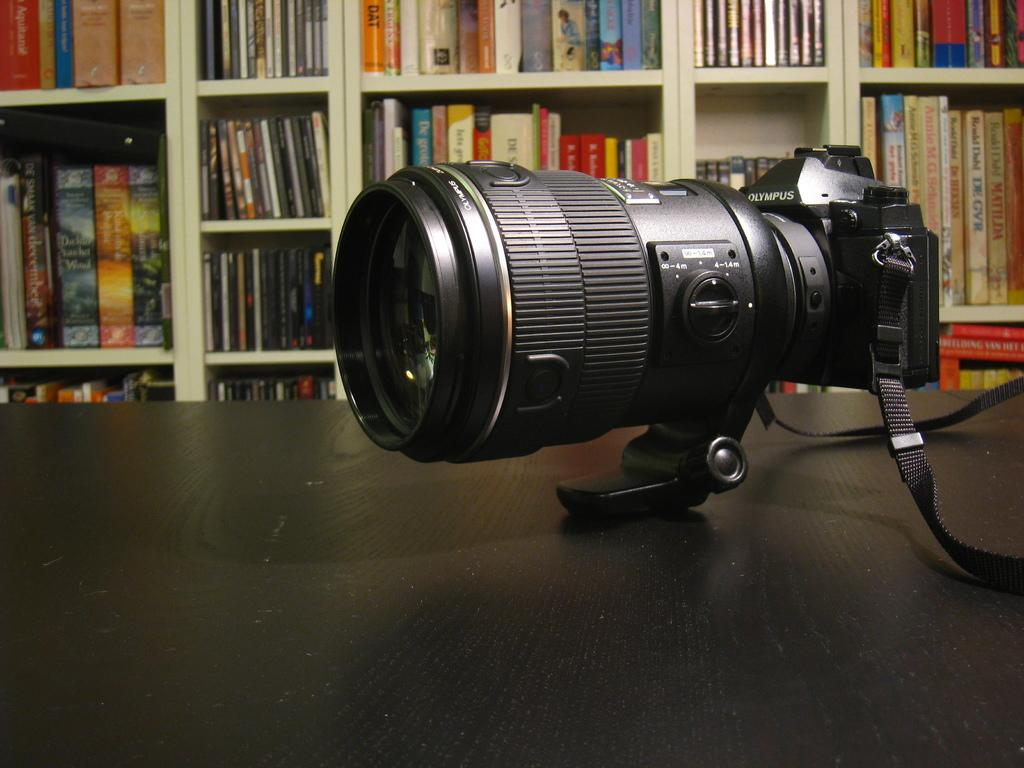What is the main subject of the image? The main subject of the image is a camera. What color is the object on which the camera is placed? The camera is on a black color object. What can be seen in the background of the image? There are shelves in the background of the image. What items are on the shelves in the background? There are books on the shelves in the background. How many chickens are visible on the shelves in the image? There are no chickens visible on the shelves in the image. What type of servant is attending to the camera in the image? There is no servant present in the image; it only shows a camera on a black object with shelves and books in the background. 